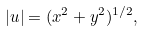<formula> <loc_0><loc_0><loc_500><loc_500>| u | = ( x ^ { 2 } + y ^ { 2 } ) ^ { 1 / 2 } ,</formula> 